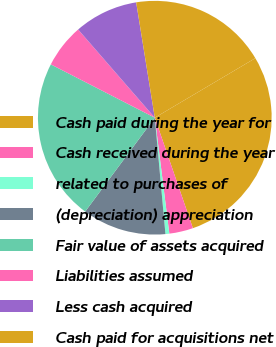Convert chart to OTSL. <chart><loc_0><loc_0><loc_500><loc_500><pie_chart><fcel>Cash paid during the year for<fcel>Cash received during the year<fcel>related to purchases of<fcel>(depreciation) appreciation<fcel>Fair value of assets acquired<fcel>Liabilities assumed<fcel>Less cash acquired<fcel>Cash paid for acquisitions net<nl><fcel>28.23%<fcel>3.3%<fcel>0.53%<fcel>11.61%<fcel>22.39%<fcel>6.07%<fcel>8.84%<fcel>19.04%<nl></chart> 